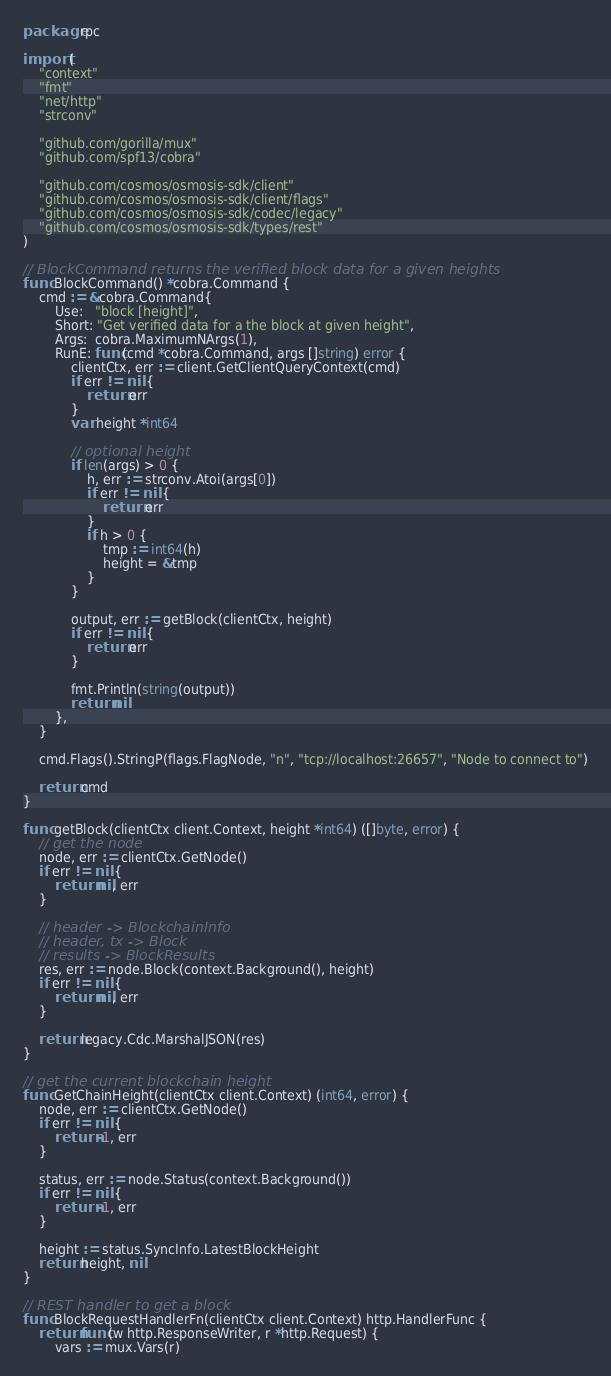<code> <loc_0><loc_0><loc_500><loc_500><_Go_>package rpc

import (
	"context"
	"fmt"
	"net/http"
	"strconv"

	"github.com/gorilla/mux"
	"github.com/spf13/cobra"

	"github.com/cosmos/osmosis-sdk/client"
	"github.com/cosmos/osmosis-sdk/client/flags"
	"github.com/cosmos/osmosis-sdk/codec/legacy"
	"github.com/cosmos/osmosis-sdk/types/rest"
)

// BlockCommand returns the verified block data for a given heights
func BlockCommand() *cobra.Command {
	cmd := &cobra.Command{
		Use:   "block [height]",
		Short: "Get verified data for a the block at given height",
		Args:  cobra.MaximumNArgs(1),
		RunE: func(cmd *cobra.Command, args []string) error {
			clientCtx, err := client.GetClientQueryContext(cmd)
			if err != nil {
				return err
			}
			var height *int64

			// optional height
			if len(args) > 0 {
				h, err := strconv.Atoi(args[0])
				if err != nil {
					return err
				}
				if h > 0 {
					tmp := int64(h)
					height = &tmp
				}
			}

			output, err := getBlock(clientCtx, height)
			if err != nil {
				return err
			}

			fmt.Println(string(output))
			return nil
		},
	}

	cmd.Flags().StringP(flags.FlagNode, "n", "tcp://localhost:26657", "Node to connect to")

	return cmd
}

func getBlock(clientCtx client.Context, height *int64) ([]byte, error) {
	// get the node
	node, err := clientCtx.GetNode()
	if err != nil {
		return nil, err
	}

	// header -> BlockchainInfo
	// header, tx -> Block
	// results -> BlockResults
	res, err := node.Block(context.Background(), height)
	if err != nil {
		return nil, err
	}

	return legacy.Cdc.MarshalJSON(res)
}

// get the current blockchain height
func GetChainHeight(clientCtx client.Context) (int64, error) {
	node, err := clientCtx.GetNode()
	if err != nil {
		return -1, err
	}

	status, err := node.Status(context.Background())
	if err != nil {
		return -1, err
	}

	height := status.SyncInfo.LatestBlockHeight
	return height, nil
}

// REST handler to get a block
func BlockRequestHandlerFn(clientCtx client.Context) http.HandlerFunc {
	return func(w http.ResponseWriter, r *http.Request) {
		vars := mux.Vars(r)
</code> 